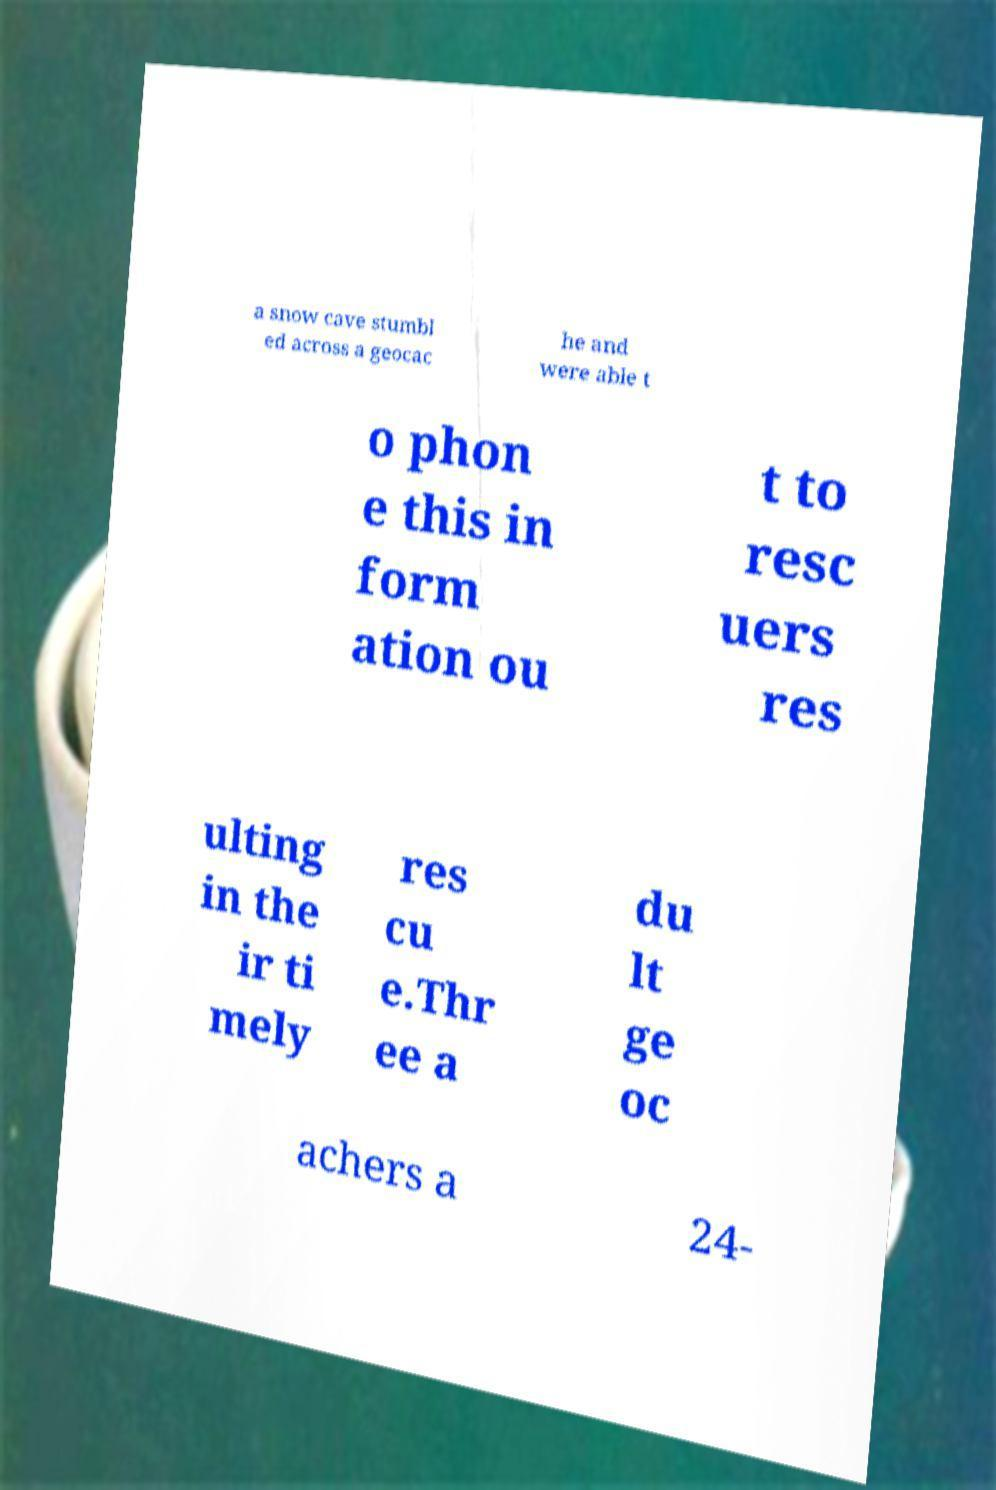What messages or text are displayed in this image? I need them in a readable, typed format. a snow cave stumbl ed across a geocac he and were able t o phon e this in form ation ou t to resc uers res ulting in the ir ti mely res cu e.Thr ee a du lt ge oc achers a 24- 